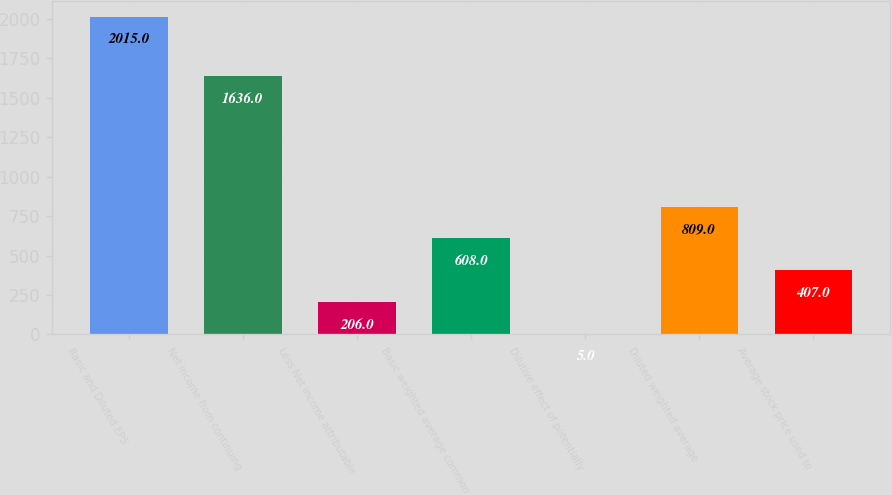<chart> <loc_0><loc_0><loc_500><loc_500><bar_chart><fcel>Basic and Diluted EPS<fcel>Net income from continuing<fcel>Less Net income attributable<fcel>Basic weighted average common<fcel>Dilutive effect of potentially<fcel>Diluted weighted average<fcel>Average stock price used to<nl><fcel>2015<fcel>1636<fcel>206<fcel>608<fcel>5<fcel>809<fcel>407<nl></chart> 